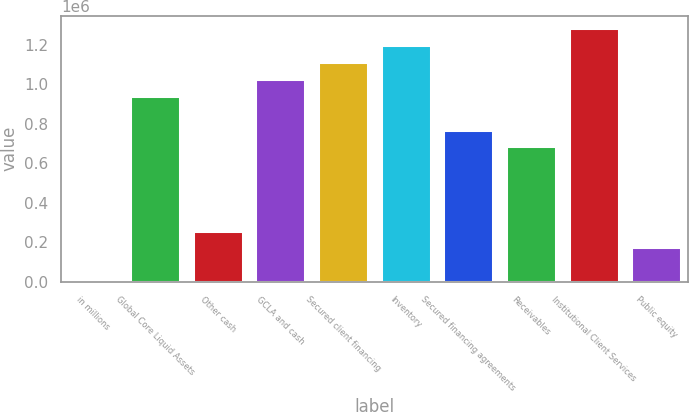Convert chart to OTSL. <chart><loc_0><loc_0><loc_500><loc_500><bar_chart><fcel>in millions<fcel>Global Core Liquid Assets<fcel>Other cash<fcel>GCLA and cash<fcel>Secured client financing<fcel>Inventory<fcel>Secured financing agreements<fcel>Receivables<fcel>Institutional Client Services<fcel>Public equity<nl><fcel>2014<fcel>941663<fcel>258282<fcel>1.02709e+06<fcel>1.11251e+06<fcel>1.19793e+06<fcel>770817<fcel>685395<fcel>1.28335e+06<fcel>172859<nl></chart> 